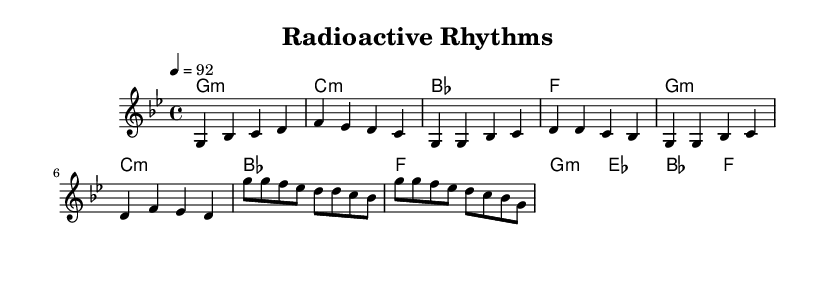What is the key signature of this music? The key signature is G minor, indicated by the presence of two flats (B♭ and E♭).
Answer: G minor What is the time signature of this piece? The time signature is 4/4, which means there are four beats in each measure and a quarter note receives one beat.
Answer: 4/4 What is the tempo marking for this score? The tempo marking is set at 92 beats per minute, which indicates the speed of the piece.
Answer: 92 How many measures are in the Chorus section? The Chorus section consists of two measures, as indicated by the grouping of notes in that section of the score.
Answer: 2 Which section of the music contains a repetition of the melody? The Verse section features the repetition of the melody in the notation, where phrases are repeated within the measures.
Answer: Verse What type of chords predominantly accompany the melody? The chords used are minor chords, contributing to the overall darker sound typical for rap music that discusses challenges.
Answer: Minor chords What is the rhythmic feel established in the Chorus? The rhythmic feel in the Chorus is characterized by syncopation, emphasizing off-beats that create a driving, engaging groove typical in rap.
Answer: Syncopation 